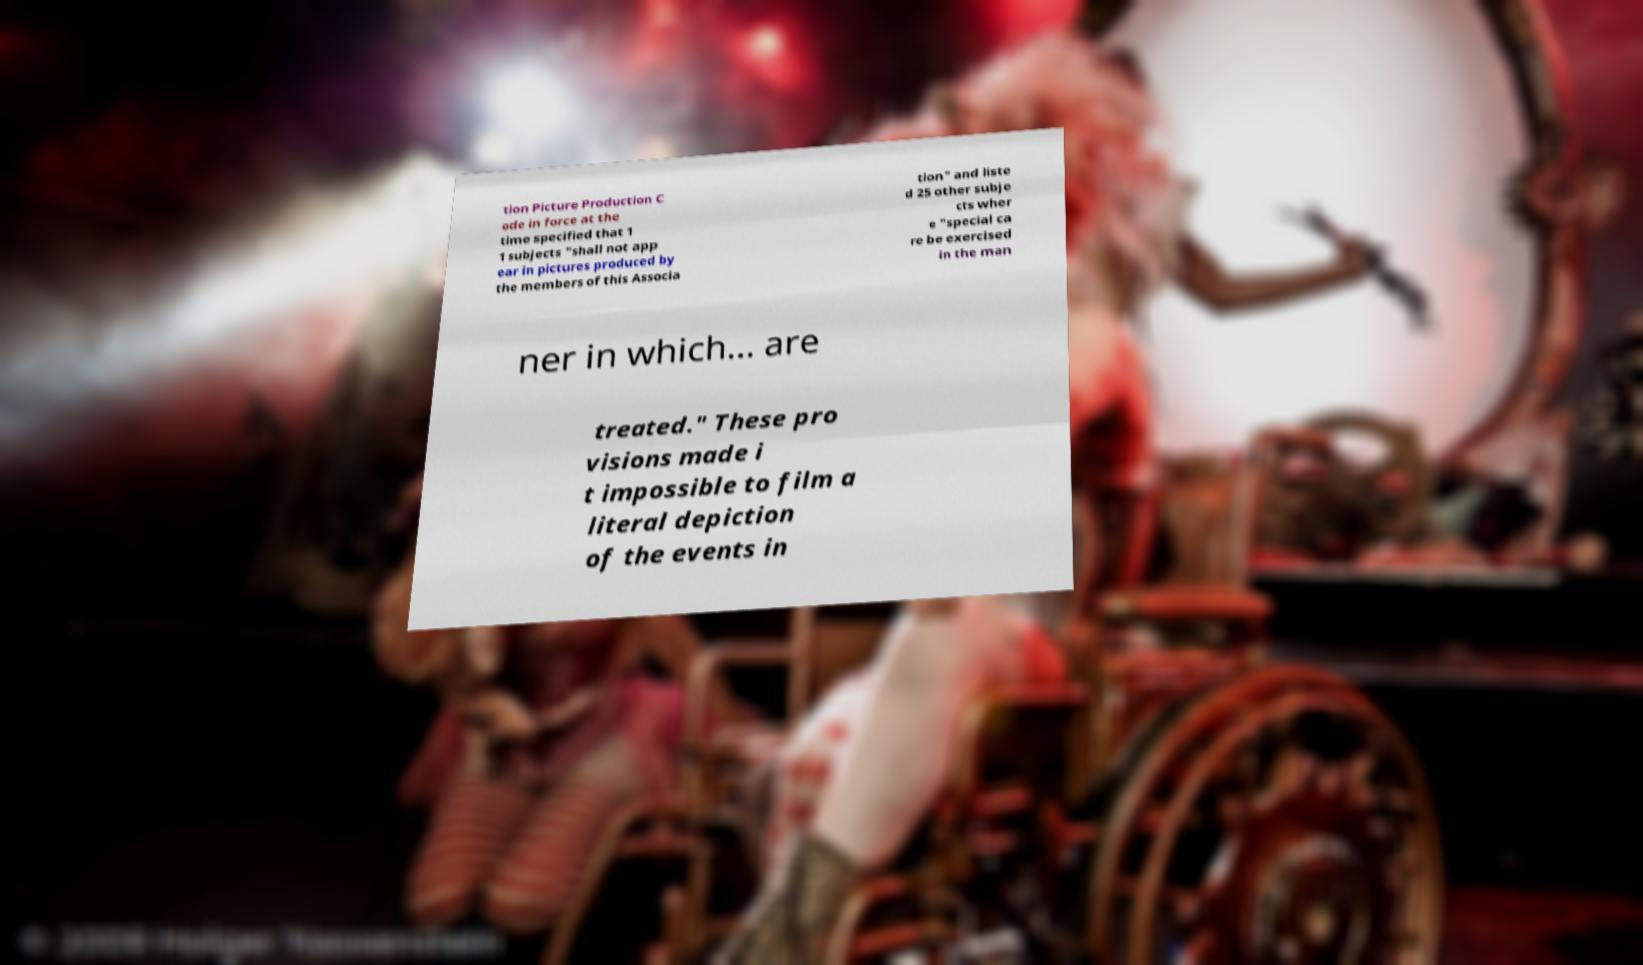Can you read and provide the text displayed in the image?This photo seems to have some interesting text. Can you extract and type it out for me? tion Picture Production C ode in force at the time specified that 1 1 subjects "shall not app ear in pictures produced by the members of this Associa tion" and liste d 25 other subje cts wher e "special ca re be exercised in the man ner in which... are treated." These pro visions made i t impossible to film a literal depiction of the events in 